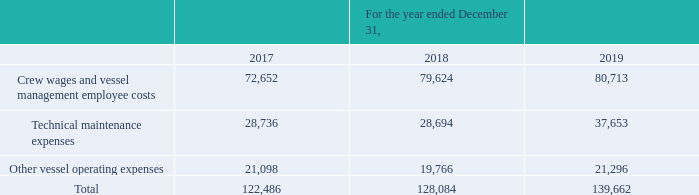GasLog Ltd. and its Subsidiaries
Notes to the consolidated financial statements (Continued)
For the years ended December 31, 2017, 2018 and 2019
(All amounts expressed in thousands of U.S. Dollars, except share and per share data)
15. Vessel Operating and Supervision Costs
An analysis of vessel operating and supervision costs is as follows:
What is being analyzed as shown in the table? Vessel operating and supervision costs. What are the components of vessel operating and supervision costs? Crew wages and vessel management employee costs, technical maintenance expenses, other vessel operating expenses. What is the total amount in 2017?
Answer scale should be: thousand. 122,486. In which year was the crew wages and vessel management employee costs the lowest? 72,652 < 79,624 < 80,713
Answer: 2017. What was the change in technical maintenance expenses from 2017 to 2018?
Answer scale should be: thousand. 28,694 - 28,736 
Answer: -42. What was the percentage change in total vessel operating and supervision costs from 2018 to 2019?
Answer scale should be: percent. (139,662 - 128,084)/128,084 
Answer: 9.04. 